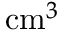Convert formula to latex. <formula><loc_0><loc_0><loc_500><loc_500>c m ^ { 3 }</formula> 